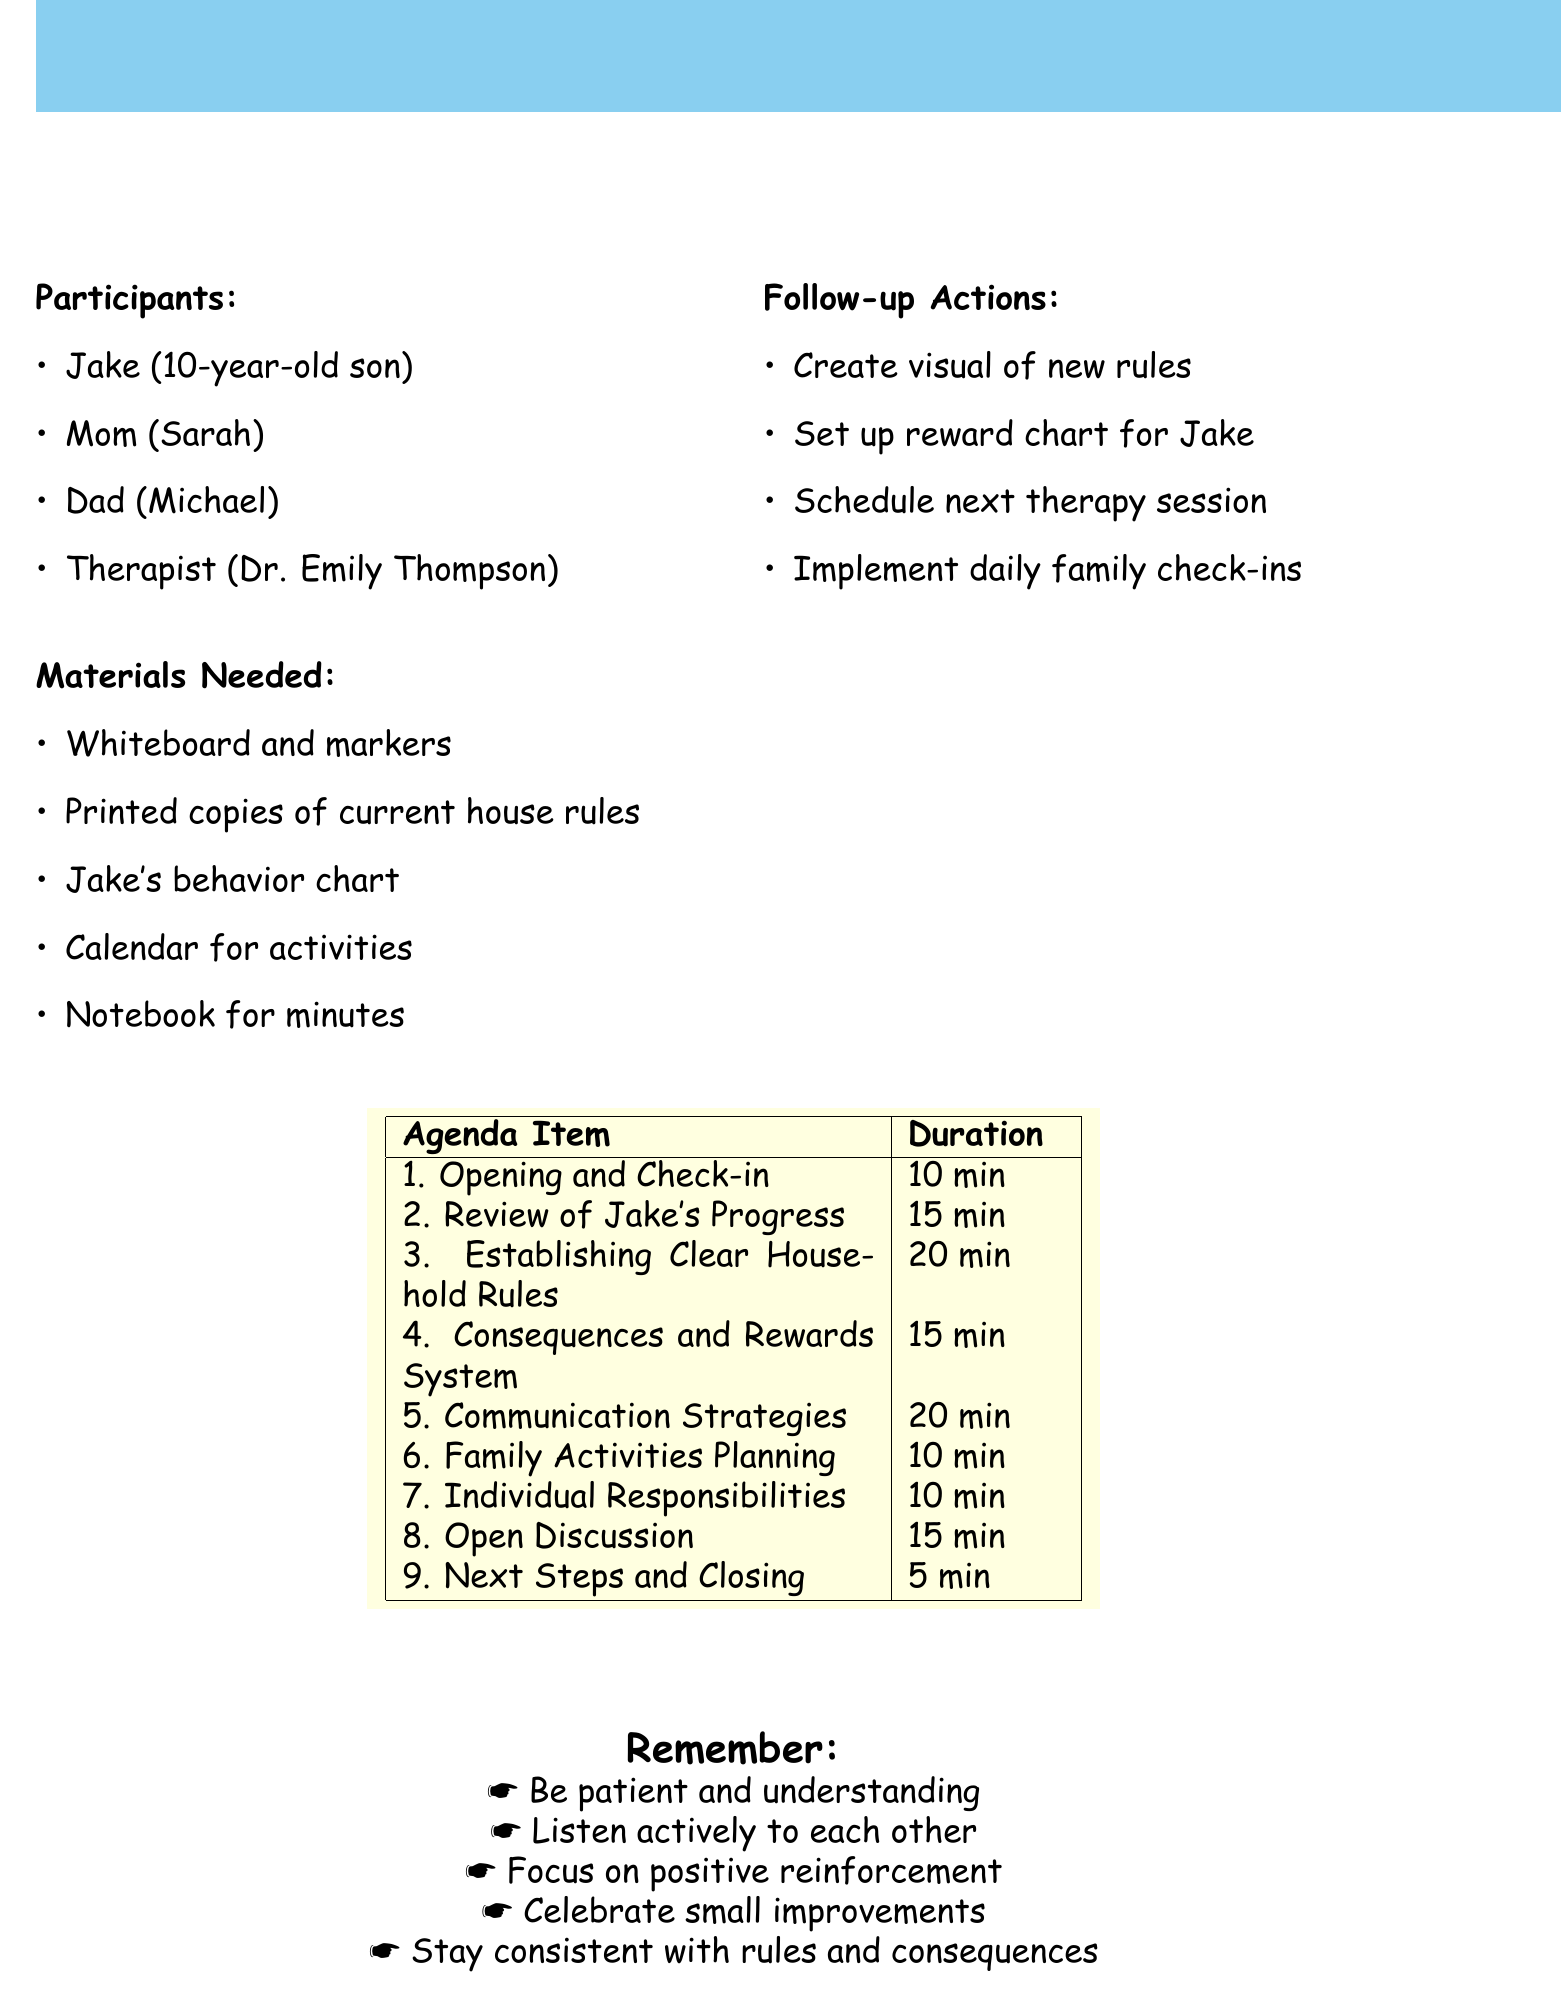What is the meeting objective? The objective is stated clearly in the document as the purpose of the family meeting, focusing on establishing clear expectations and improving family dynamics for Jake's well-being.
Answer: To establish clear expectations and improve family dynamics for Jake's well-being Who are the participants in the meeting? The document lists the family members and therapist participating in the meeting.
Answer: Jake (10-year-old son), Mom (Sarah), Dad (Michael), Therapist (Dr. Emily Thompson) How long is the discussion on establishing clear household rules? The duration for this agenda item is specified in the document.
Answer: 20 minutes What material is needed to record meeting minutes? The document mentions a specific item required for taking notes during the meeting.
Answer: Notebook for recording meeting minutes What will each family member do during the Opening and Check-in? The description in the document outlines the specific activity for this agenda item.
Answer: Share their mood and one positive thing from the week How many minutes are allocated for the Open Discussion? The document provides the duration for each agenda item, including this one.
Answer: 15 minutes What is one follow-up action after the meeting? The document details several follow-up actions that should be completed after the meeting.
Answer: Create and display a visual representation of new household rules What communication strategy will be discussed during the meeting? The document describes a specific technique that will be guided by Dr. Thompson during the meeting.
Answer: Effective communication techniques, including active listening and 'I' statements What type of system will be developed regarding rules? The document mentions the nature of the system to be discussed in one of the agenda items.
Answer: Fair system of consequences for rule-breaking and rewards for positive behavior 